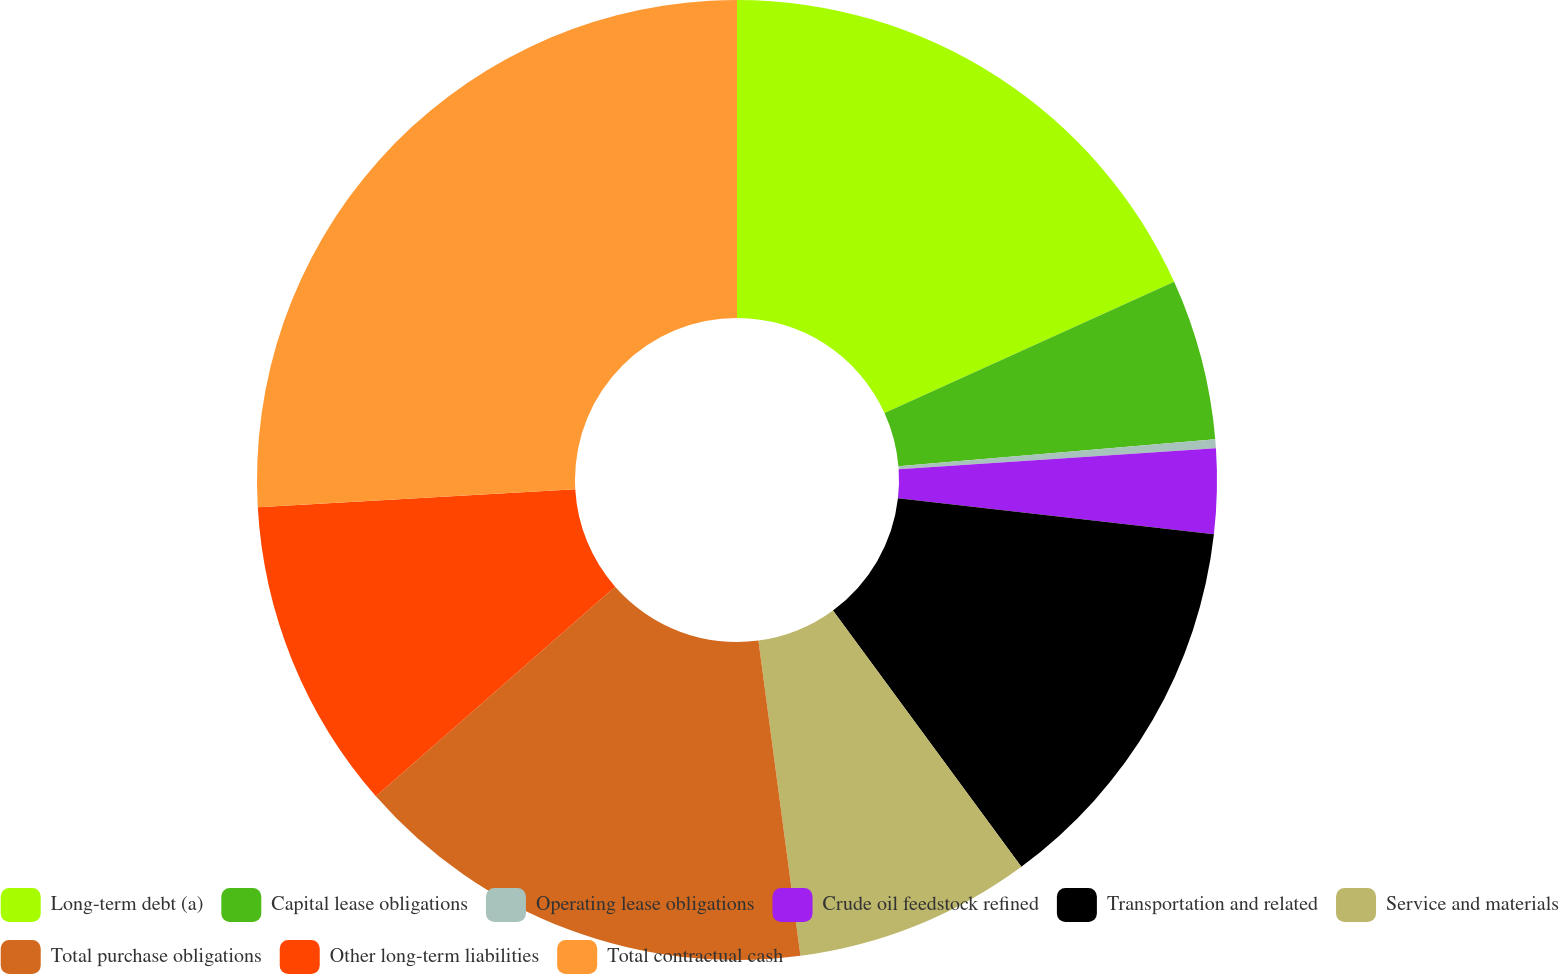Convert chart to OTSL. <chart><loc_0><loc_0><loc_500><loc_500><pie_chart><fcel>Long-term debt (a)<fcel>Capital lease obligations<fcel>Operating lease obligations<fcel>Crude oil feedstock refined<fcel>Transportation and related<fcel>Service and materials<fcel>Total purchase obligations<fcel>Other long-term liabilities<fcel>Total contractual cash<nl><fcel>18.22%<fcel>5.42%<fcel>0.3%<fcel>2.86%<fcel>13.1%<fcel>7.98%<fcel>15.66%<fcel>10.54%<fcel>25.9%<nl></chart> 